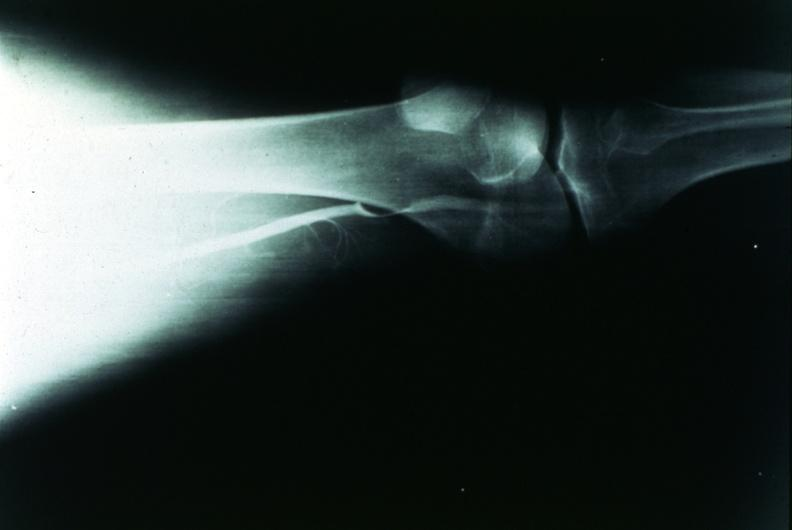what is present?
Answer the question using a single word or phrase. Joints 